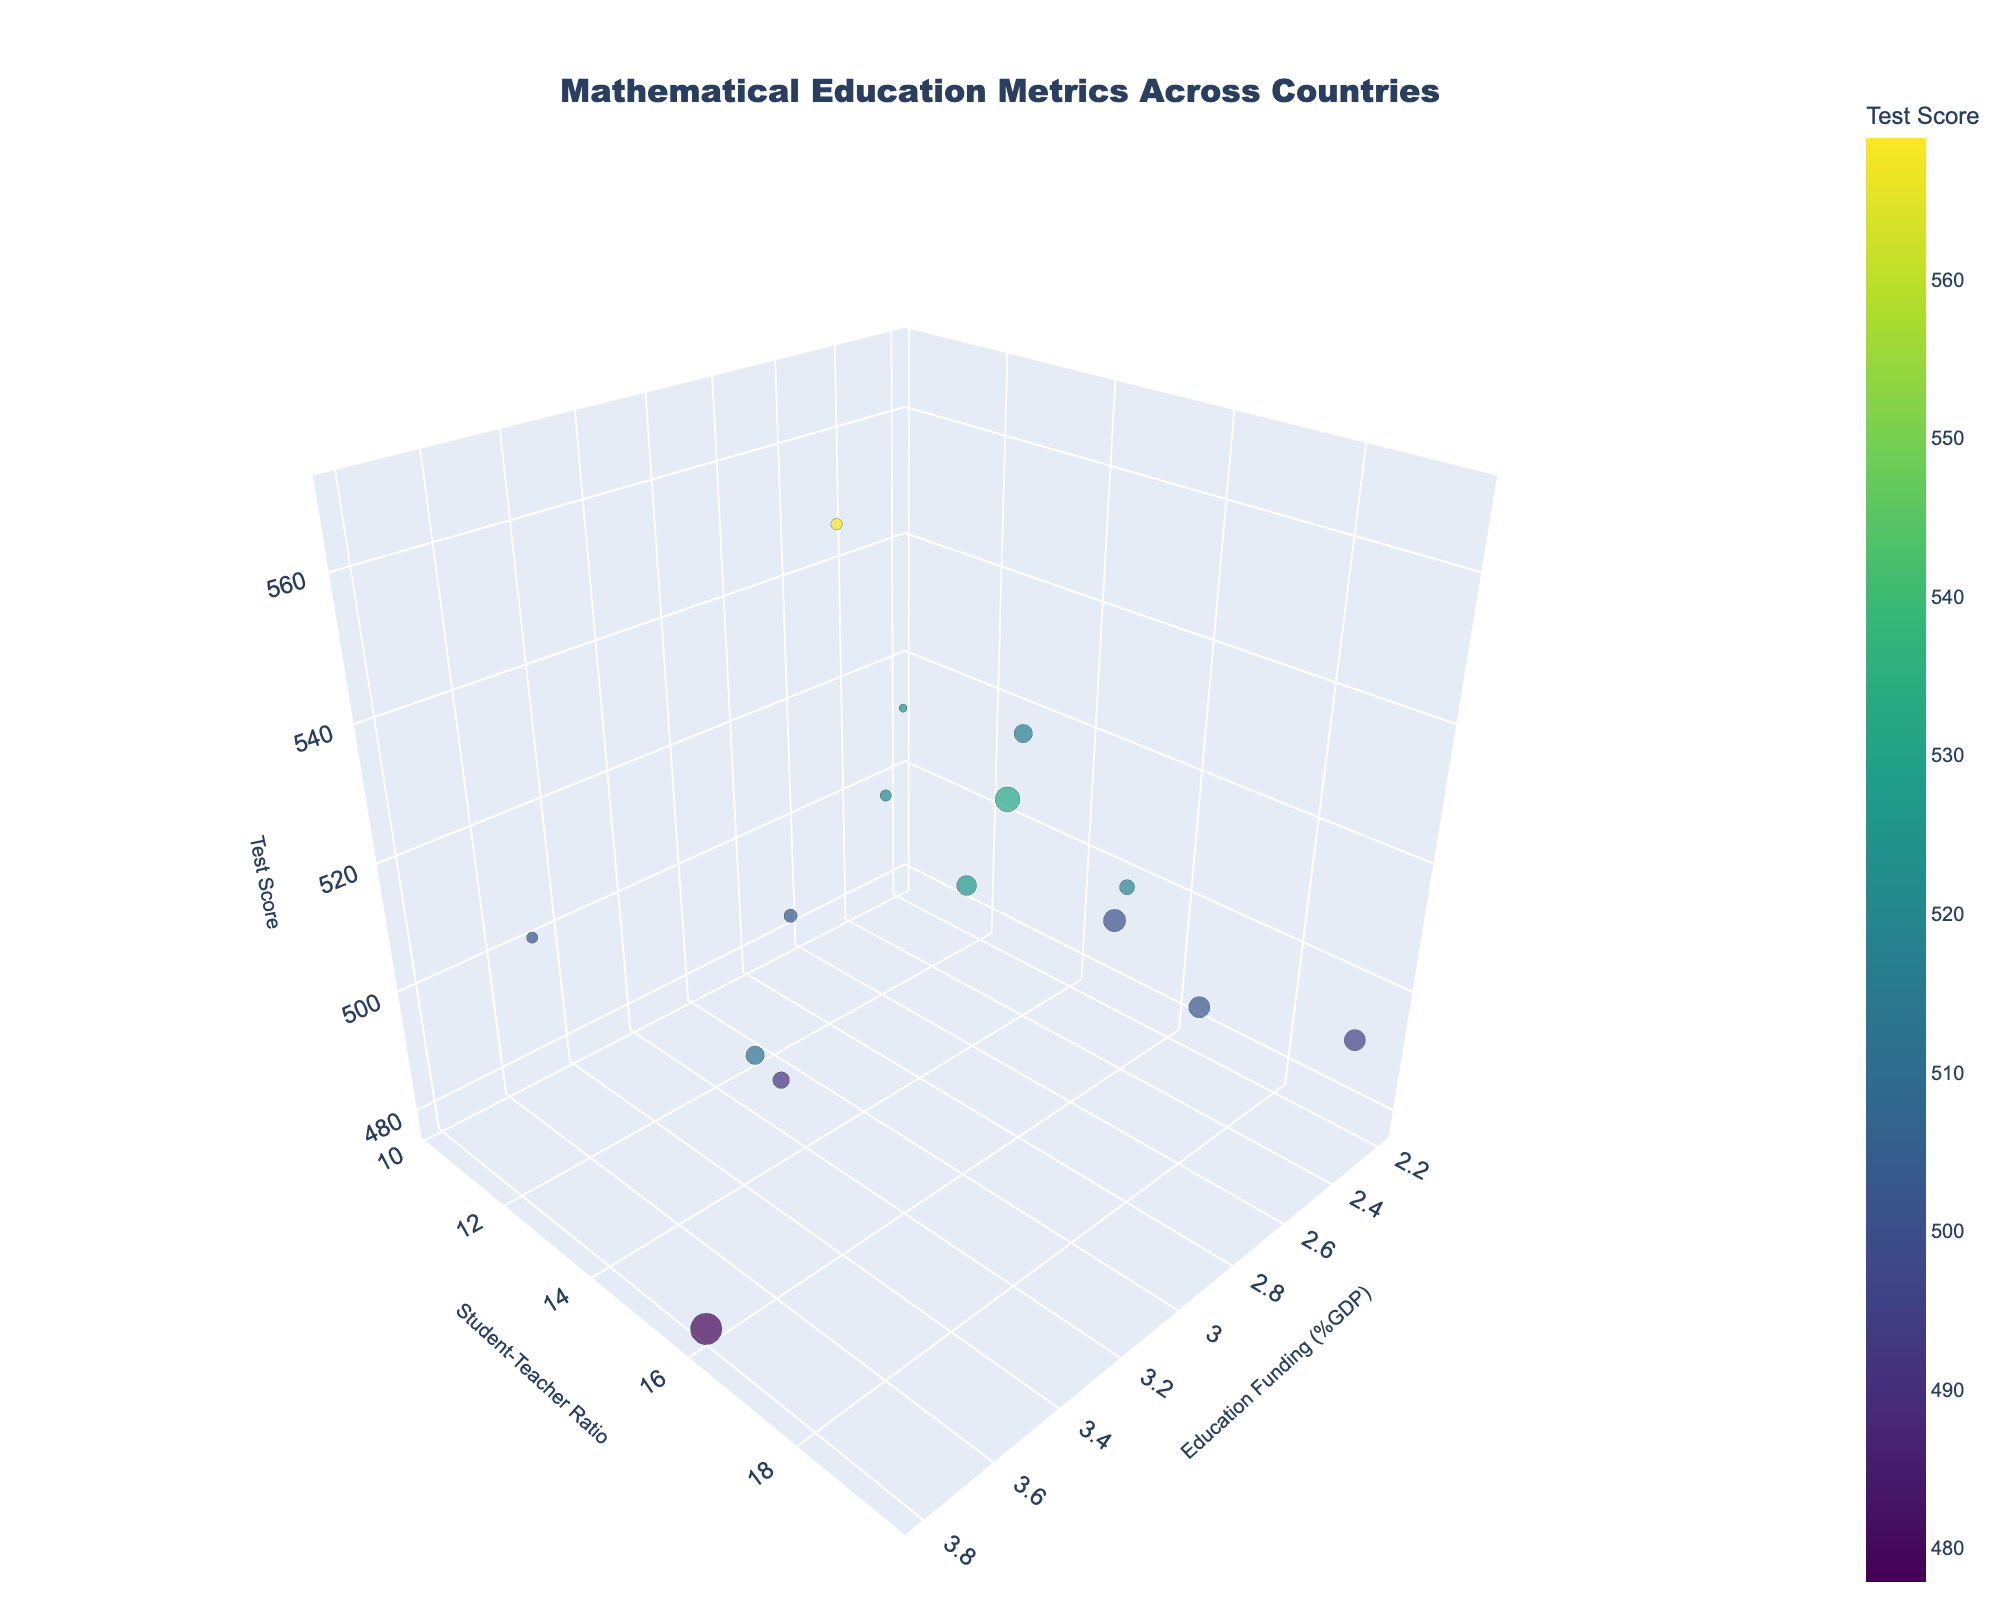What is the title of the 3D bubble chart? The title of the chart is usually displayed at the top and it summarises the main theme of the chart. In this chart, the title is 'Mathematical Education Metrics Across Countries'.
Answer: Mathematical Education Metrics Across Countries Which country has the highest standardized test score? By looking at the z-axis (standardized test scores), we identify which bubble is positioned at the highest point. The highest standardized test score is seen in Singapore.
Answer: Singapore How is the color of the bubbles related to the standardized test score? The color of the bubbles is mapped to the standardized test score, where different colors represent different score ranges. This can be seen in the color legend on the chart.
Answer: The bubble color represents the standardized test score What country has the biggest bubble, and what does it represent? The size of the bubbles is based on the population of the country. The United States has the largest bubble, indicating it has the largest population among the countries represented.
Answer: United States What is the trend between education funding and test scores? By examining the relationship along the x-axis (education funding) and z-axis (test scores), we can identify if there's a visible trend. Generally, higher funding seems to correlate with higher test scores, although there are exceptions.
Answer: Generally positive Which country has the highest student-teacher ratio and how does its test score compare to others? Checking bubbles along the y-axis (student-teacher ratio), we identify the country at the highest position. France has the highest student-teacher ratio. Its test score (~495) is moderate in comparison to others.
Answer: France; moderate What is the student-teacher ratio for Finland? Locate Finland on the chart and look at its position on the y-axis, representing the student-teacher ratio. For Finland, the student-teacher ratio is shown to be 13.3.
Answer: 13.3 Comparing Canada and Germany, which country has a higher standardized test score? Identify the positions of Canada and Germany based on the hover names or country labels, then compare their positions along the z-axis. Canada’s score is higher (512) compared to Germany’s (500).
Answer: Canada Which countries spend more than 3% of GDP on math education? Identify the bubbles positioned to the right of the 3% mark on the x-axis. The countries are South Korea, Singapore, Canada, Australia, and Norway.
Answer: South Korea, Singapore, Canada, Australia, Norway Which country has both a low student-teacher ratio and high test score? Look for bubbles at lower positions on the y-axis (student-teacher ratio) and at higher positions on the z-axis (test scores). Estonia and Finland are such countries, with Estonia having slightly higher test scores.
Answer: Estonia 